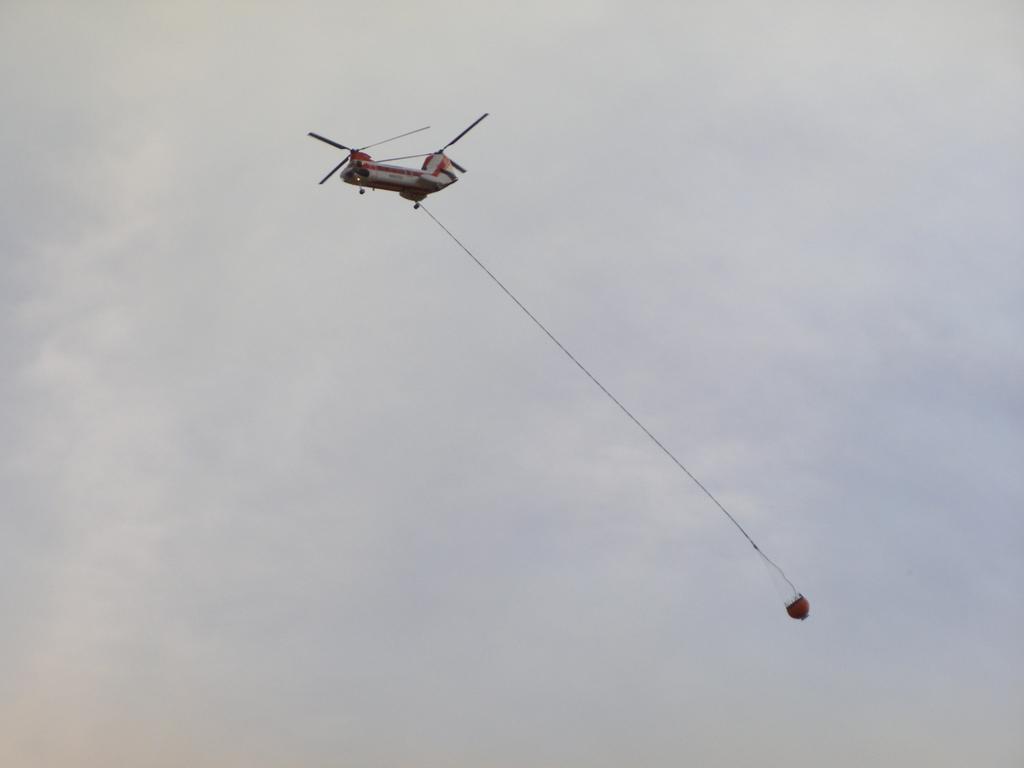Can you describe this image briefly? In the image we can see a flying jet and to it there is a rope attached and to the end of the rope there is an object. And the cloudy sky. 